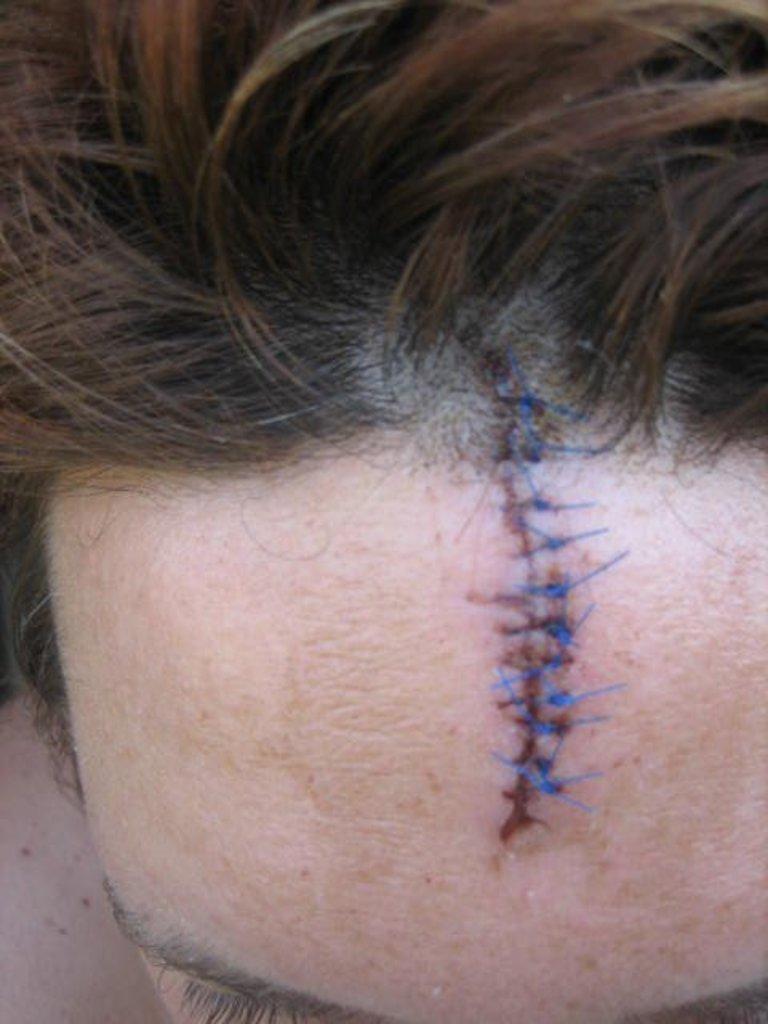Describe this image in one or two sentences. In this image we can see a person's forehead and hair. 